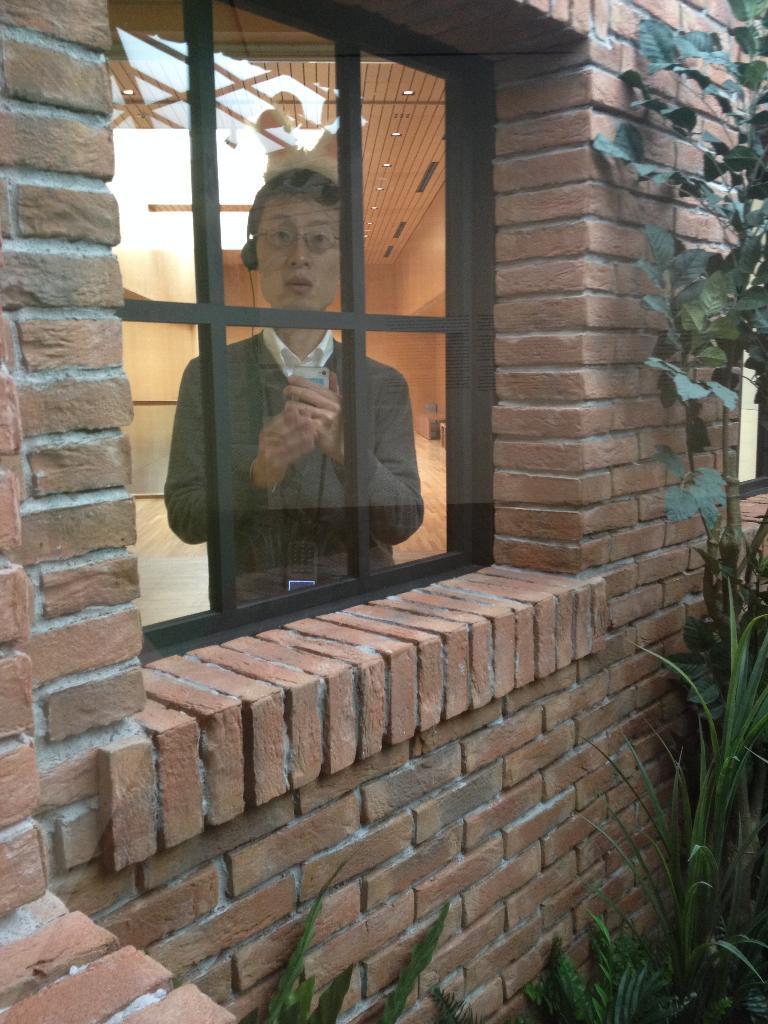In one or two sentences, can you explain what this image depicts? In this image, we can see a brick wall, we can see a glass window, there is a man standing at the window, we can see some plants. 